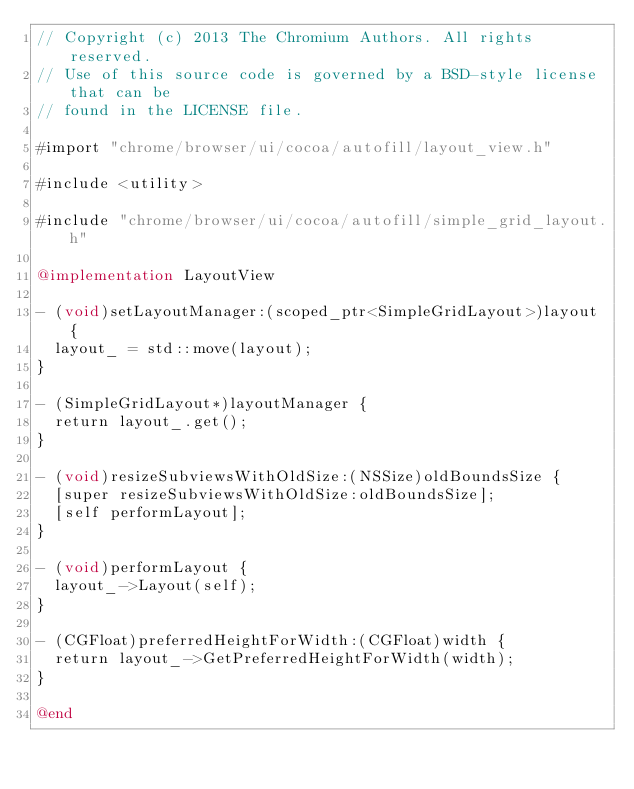<code> <loc_0><loc_0><loc_500><loc_500><_ObjectiveC_>// Copyright (c) 2013 The Chromium Authors. All rights reserved.
// Use of this source code is governed by a BSD-style license that can be
// found in the LICENSE file.

#import "chrome/browser/ui/cocoa/autofill/layout_view.h"

#include <utility>

#include "chrome/browser/ui/cocoa/autofill/simple_grid_layout.h"

@implementation LayoutView

- (void)setLayoutManager:(scoped_ptr<SimpleGridLayout>)layout {
  layout_ = std::move(layout);
}

- (SimpleGridLayout*)layoutManager {
  return layout_.get();
}

- (void)resizeSubviewsWithOldSize:(NSSize)oldBoundsSize {
  [super resizeSubviewsWithOldSize:oldBoundsSize];
  [self performLayout];
}

- (void)performLayout {
  layout_->Layout(self);
}

- (CGFloat)preferredHeightForWidth:(CGFloat)width {
  return layout_->GetPreferredHeightForWidth(width);
}

@end
</code> 